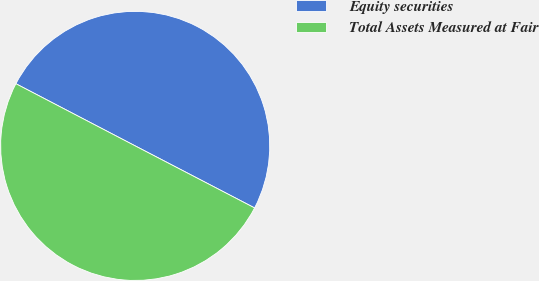Convert chart to OTSL. <chart><loc_0><loc_0><loc_500><loc_500><pie_chart><fcel>Equity securities<fcel>Total Assets Measured at Fair<nl><fcel>49.98%<fcel>50.02%<nl></chart> 